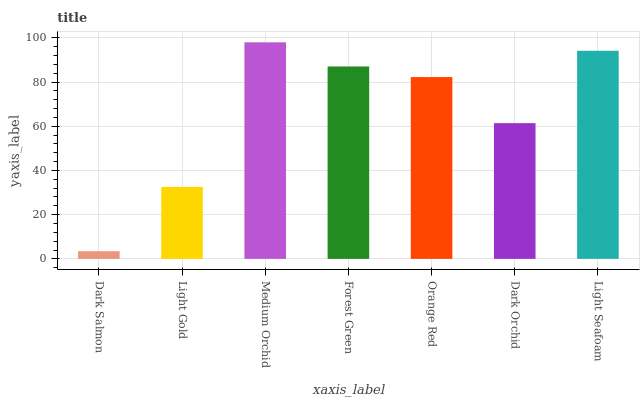Is Dark Salmon the minimum?
Answer yes or no. Yes. Is Medium Orchid the maximum?
Answer yes or no. Yes. Is Light Gold the minimum?
Answer yes or no. No. Is Light Gold the maximum?
Answer yes or no. No. Is Light Gold greater than Dark Salmon?
Answer yes or no. Yes. Is Dark Salmon less than Light Gold?
Answer yes or no. Yes. Is Dark Salmon greater than Light Gold?
Answer yes or no. No. Is Light Gold less than Dark Salmon?
Answer yes or no. No. Is Orange Red the high median?
Answer yes or no. Yes. Is Orange Red the low median?
Answer yes or no. Yes. Is Light Seafoam the high median?
Answer yes or no. No. Is Light Gold the low median?
Answer yes or no. No. 